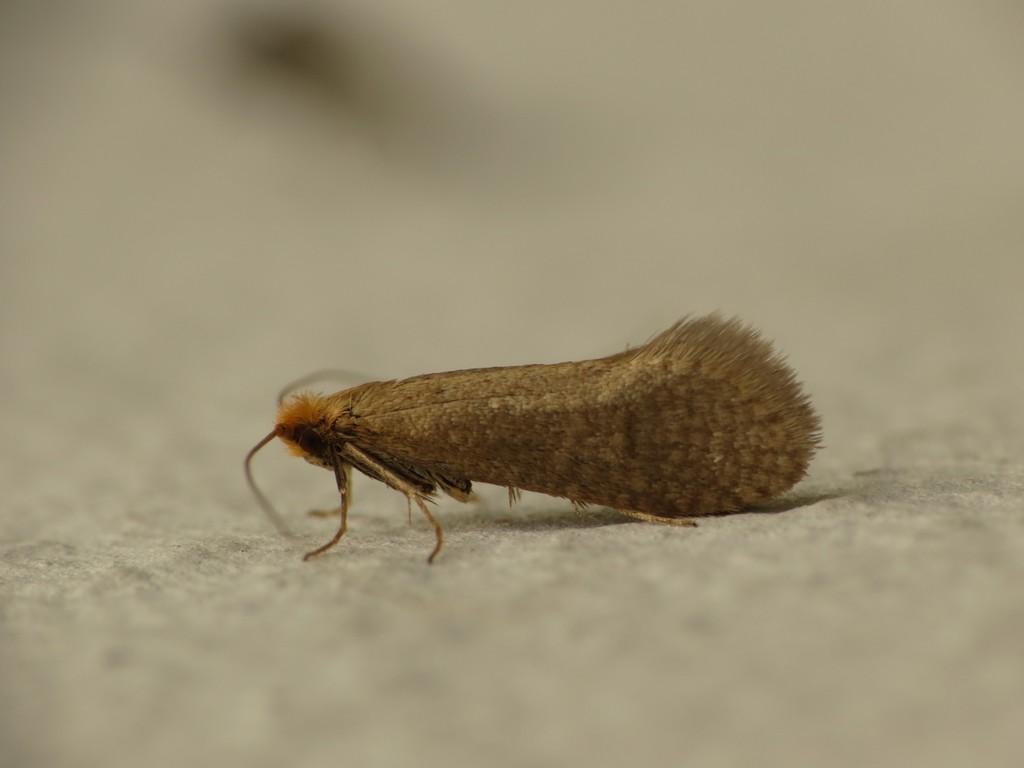Could you give a brief overview of what you see in this image? In this picture there is an insect in the center of the image. 